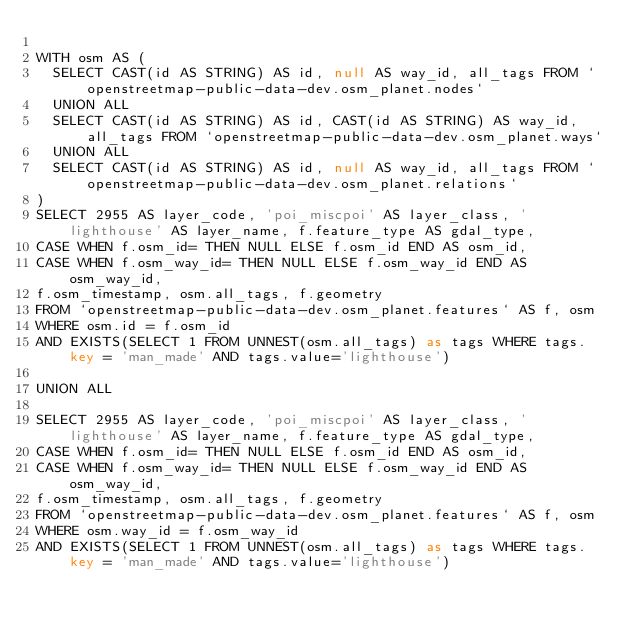Convert code to text. <code><loc_0><loc_0><loc_500><loc_500><_SQL_>
WITH osm AS (
  SELECT CAST(id AS STRING) AS id, null AS way_id, all_tags FROM `openstreetmap-public-data-dev.osm_planet.nodes`
  UNION ALL
  SELECT CAST(id AS STRING) AS id, CAST(id AS STRING) AS way_id, all_tags FROM `openstreetmap-public-data-dev.osm_planet.ways`
  UNION ALL
  SELECT CAST(id AS STRING) AS id, null AS way_id, all_tags FROM `openstreetmap-public-data-dev.osm_planet.relations`
)
SELECT 2955 AS layer_code, 'poi_miscpoi' AS layer_class, 'lighthouse' AS layer_name, f.feature_type AS gdal_type,
CASE WHEN f.osm_id= THEN NULL ELSE f.osm_id END AS osm_id,
CASE WHEN f.osm_way_id= THEN NULL ELSE f.osm_way_id END AS osm_way_id,
f.osm_timestamp, osm.all_tags, f.geometry
FROM `openstreetmap-public-data-dev.osm_planet.features` AS f, osm
WHERE osm.id = f.osm_id
AND EXISTS(SELECT 1 FROM UNNEST(osm.all_tags) as tags WHERE tags.key = 'man_made' AND tags.value='lighthouse')

UNION ALL

SELECT 2955 AS layer_code, 'poi_miscpoi' AS layer_class, 'lighthouse' AS layer_name, f.feature_type AS gdal_type,
CASE WHEN f.osm_id= THEN NULL ELSE f.osm_id END AS osm_id,
CASE WHEN f.osm_way_id= THEN NULL ELSE f.osm_way_id END AS osm_way_id,
f.osm_timestamp, osm.all_tags, f.geometry
FROM `openstreetmap-public-data-dev.osm_planet.features` AS f, osm
WHERE osm.way_id = f.osm_way_id
AND EXISTS(SELECT 1 FROM UNNEST(osm.all_tags) as tags WHERE tags.key = 'man_made' AND tags.value='lighthouse')

</code> 